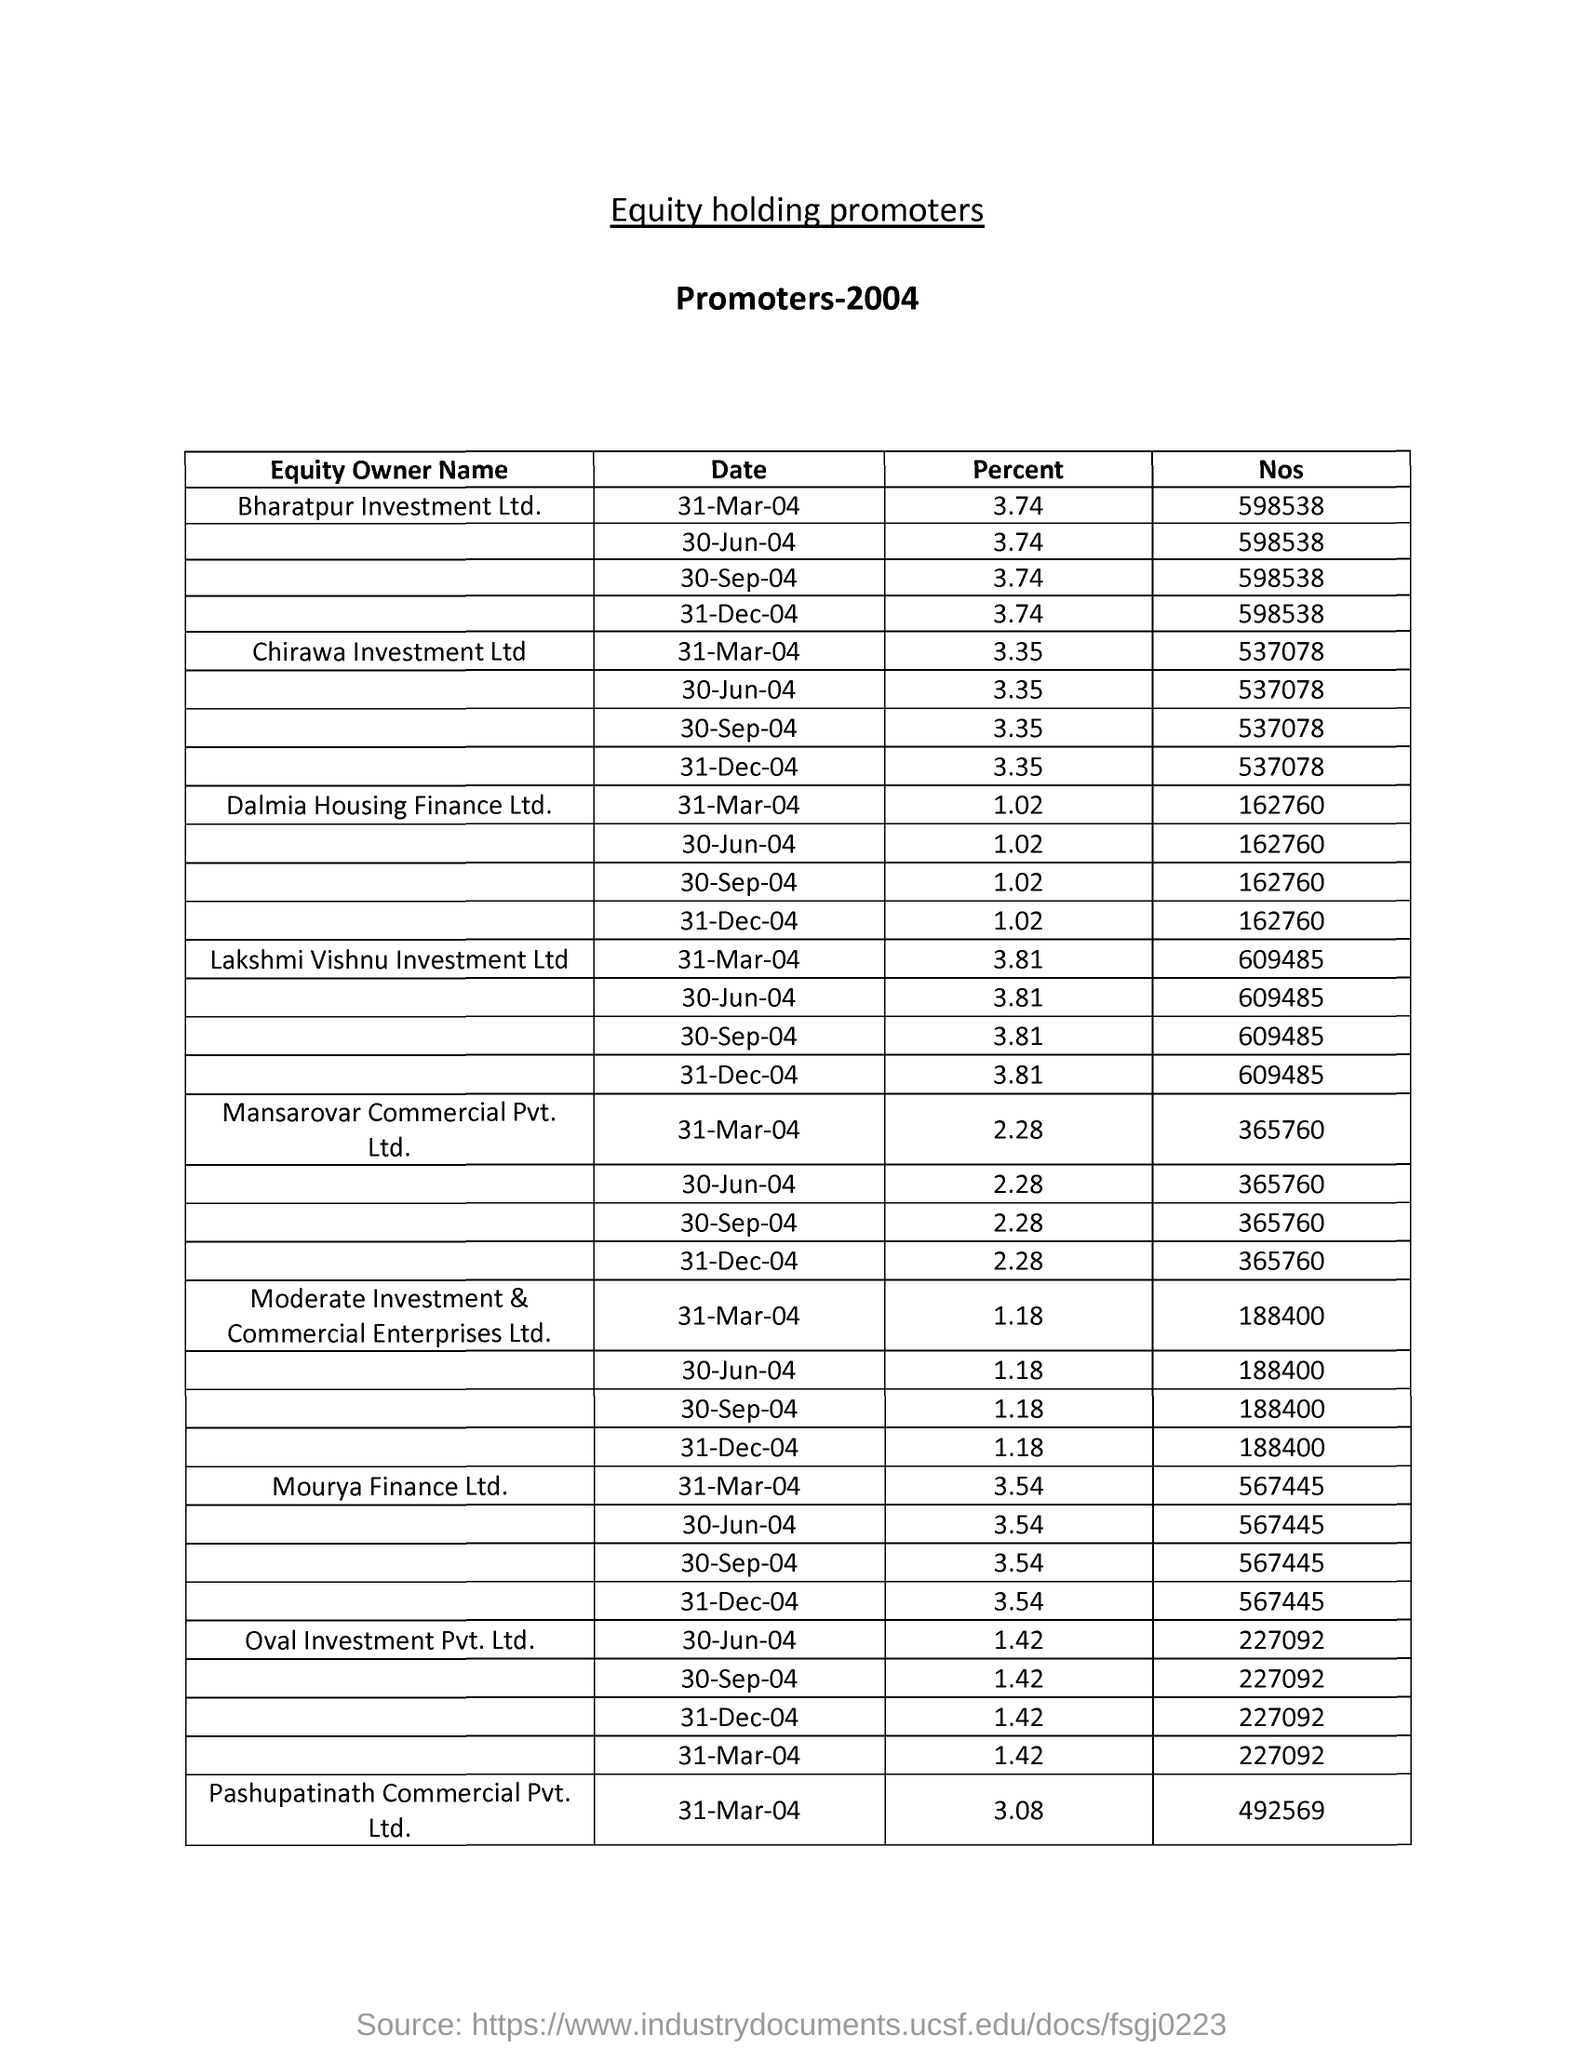What is the title?
Your response must be concise. Equity holding promoters. The data is of which year?
Ensure brevity in your answer.  2004. What is the percent holdings of bharatpur investment ltd. as on 31-mar-04?
Provide a succinct answer. 3.74. What is the nos of equity holdings of chirawa investment ltd as on 31-mar-04?
Offer a terse response. 537078. 